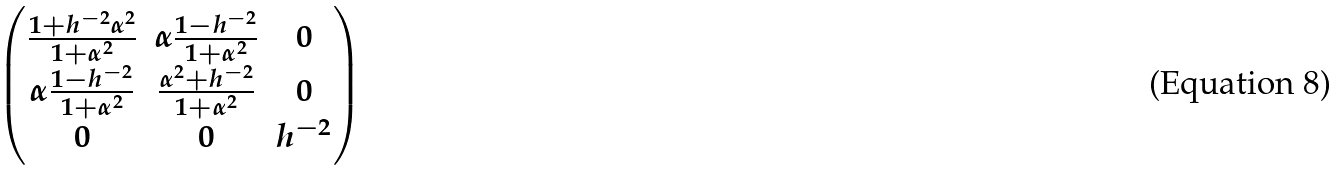Convert formula to latex. <formula><loc_0><loc_0><loc_500><loc_500>\begin{pmatrix} \frac { 1 + h ^ { - 2 } \alpha ^ { 2 } } { 1 + \alpha ^ { 2 } } & \alpha \frac { 1 - h ^ { - 2 } } { 1 + \alpha ^ { 2 } } & 0 \\ \alpha \frac { 1 - h ^ { - 2 } } { 1 + \alpha ^ { 2 } } & \frac { \alpha ^ { 2 } + h ^ { - 2 } } { 1 + \alpha ^ { 2 } } & 0 \\ 0 & 0 & h ^ { - 2 } \end{pmatrix}</formula> 